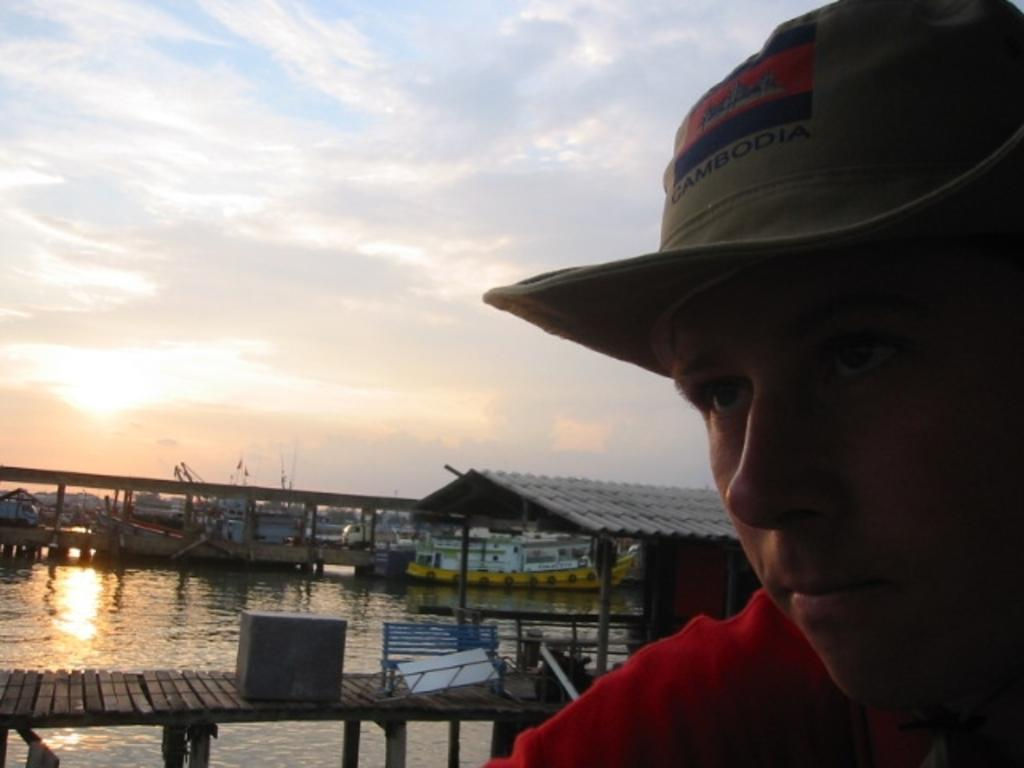Who is present in the image? There is a man in the image. What can be seen in the background of the image? There is a walkway bridge, a shed, ships at the deck, and the sky visible in the background of the image. What is the condition of the sky in the image? The sky is visible in the background of the image, and there are clouds present. What is the man's financial situation in the image? There is no information about the man's financial situation in the image. What day of the week is depicted in the image? The day of the week is not mentioned or depicted in the image. 